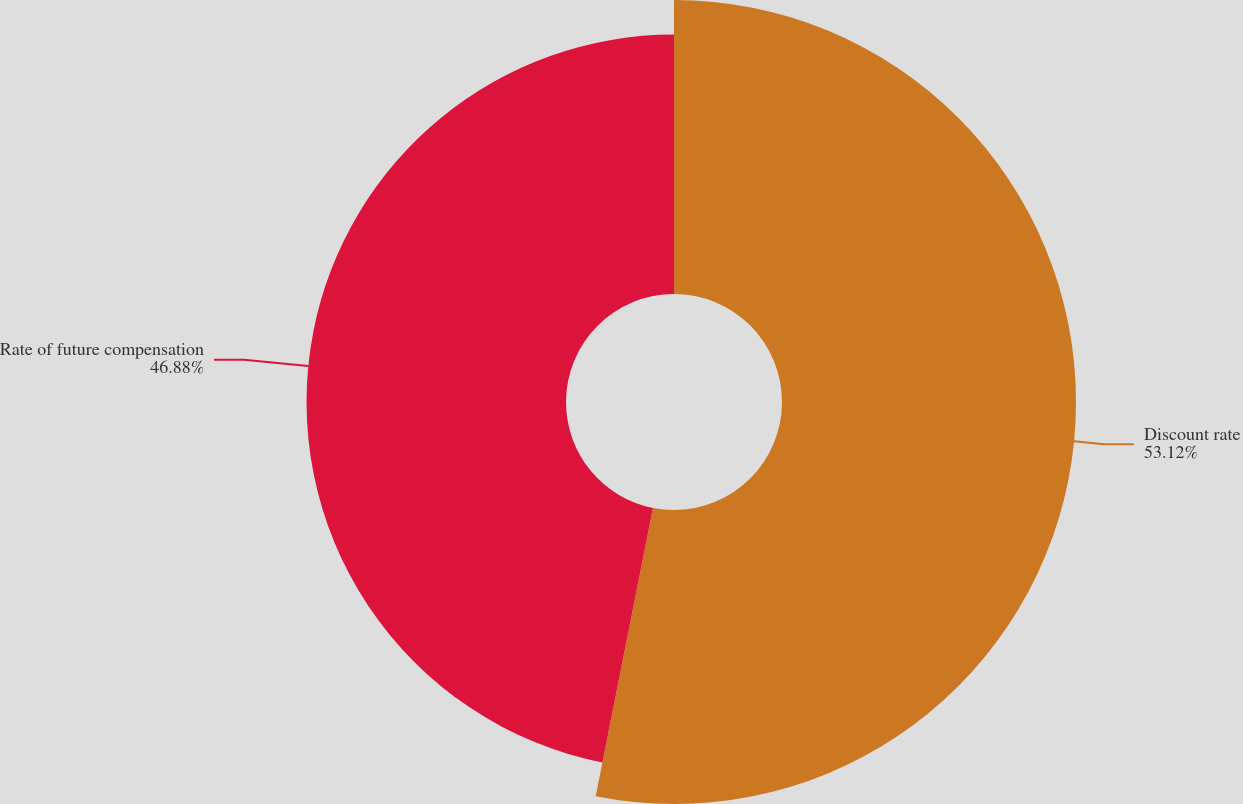Convert chart. <chart><loc_0><loc_0><loc_500><loc_500><pie_chart><fcel>Discount rate<fcel>Rate of future compensation<nl><fcel>53.12%<fcel>46.88%<nl></chart> 